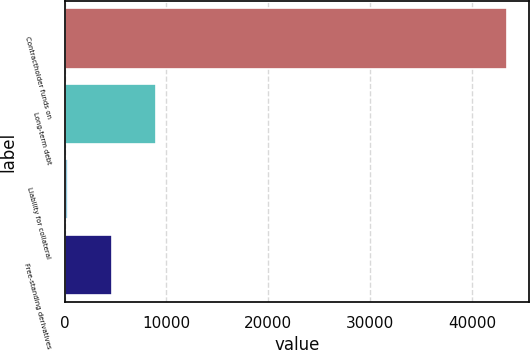Convert chart to OTSL. <chart><loc_0><loc_0><loc_500><loc_500><bar_chart><fcel>Contractholder funds on<fcel>Long-term debt<fcel>Liability for collateral<fcel>Free-standing derivatives<nl><fcel>43479<fcel>8967.8<fcel>340<fcel>4653.9<nl></chart> 